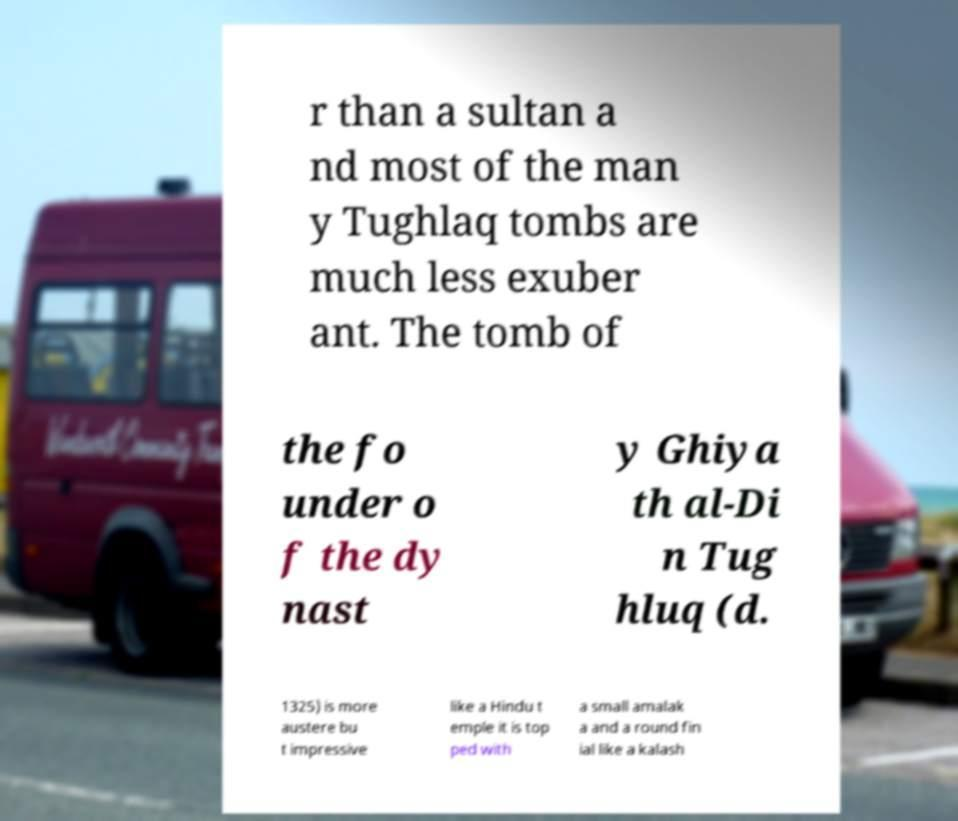Please identify and transcribe the text found in this image. r than a sultan a nd most of the man y Tughlaq tombs are much less exuber ant. The tomb of the fo under o f the dy nast y Ghiya th al-Di n Tug hluq (d. 1325) is more austere bu t impressive like a Hindu t emple it is top ped with a small amalak a and a round fin ial like a kalash 